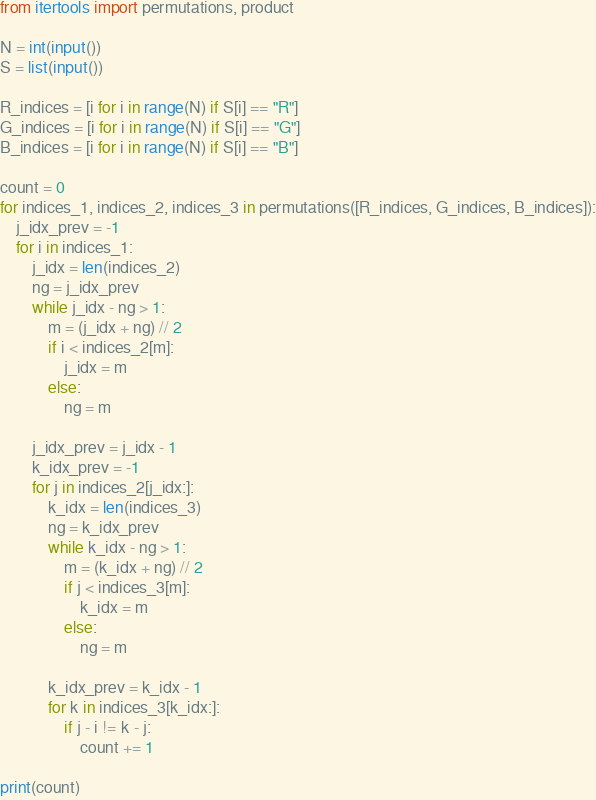Convert code to text. <code><loc_0><loc_0><loc_500><loc_500><_Python_>from itertools import permutations, product

N = int(input())
S = list(input())

R_indices = [i for i in range(N) if S[i] == "R"]
G_indices = [i for i in range(N) if S[i] == "G"]
B_indices = [i for i in range(N) if S[i] == "B"]

count = 0
for indices_1, indices_2, indices_3 in permutations([R_indices, G_indices, B_indices]):
    j_idx_prev = -1
    for i in indices_1:
        j_idx = len(indices_2)
        ng = j_idx_prev
        while j_idx - ng > 1:
            m = (j_idx + ng) // 2
            if i < indices_2[m]:
                j_idx = m
            else:
                ng = m

        j_idx_prev = j_idx - 1
        k_idx_prev = -1
        for j in indices_2[j_idx:]:
            k_idx = len(indices_3)
            ng = k_idx_prev
            while k_idx - ng > 1:
                m = (k_idx + ng) // 2
                if j < indices_3[m]:
                    k_idx = m
                else:
                    ng = m

            k_idx_prev = k_idx - 1
            for k in indices_3[k_idx:]:
                if j - i != k - j:
                    count += 1

print(count)</code> 